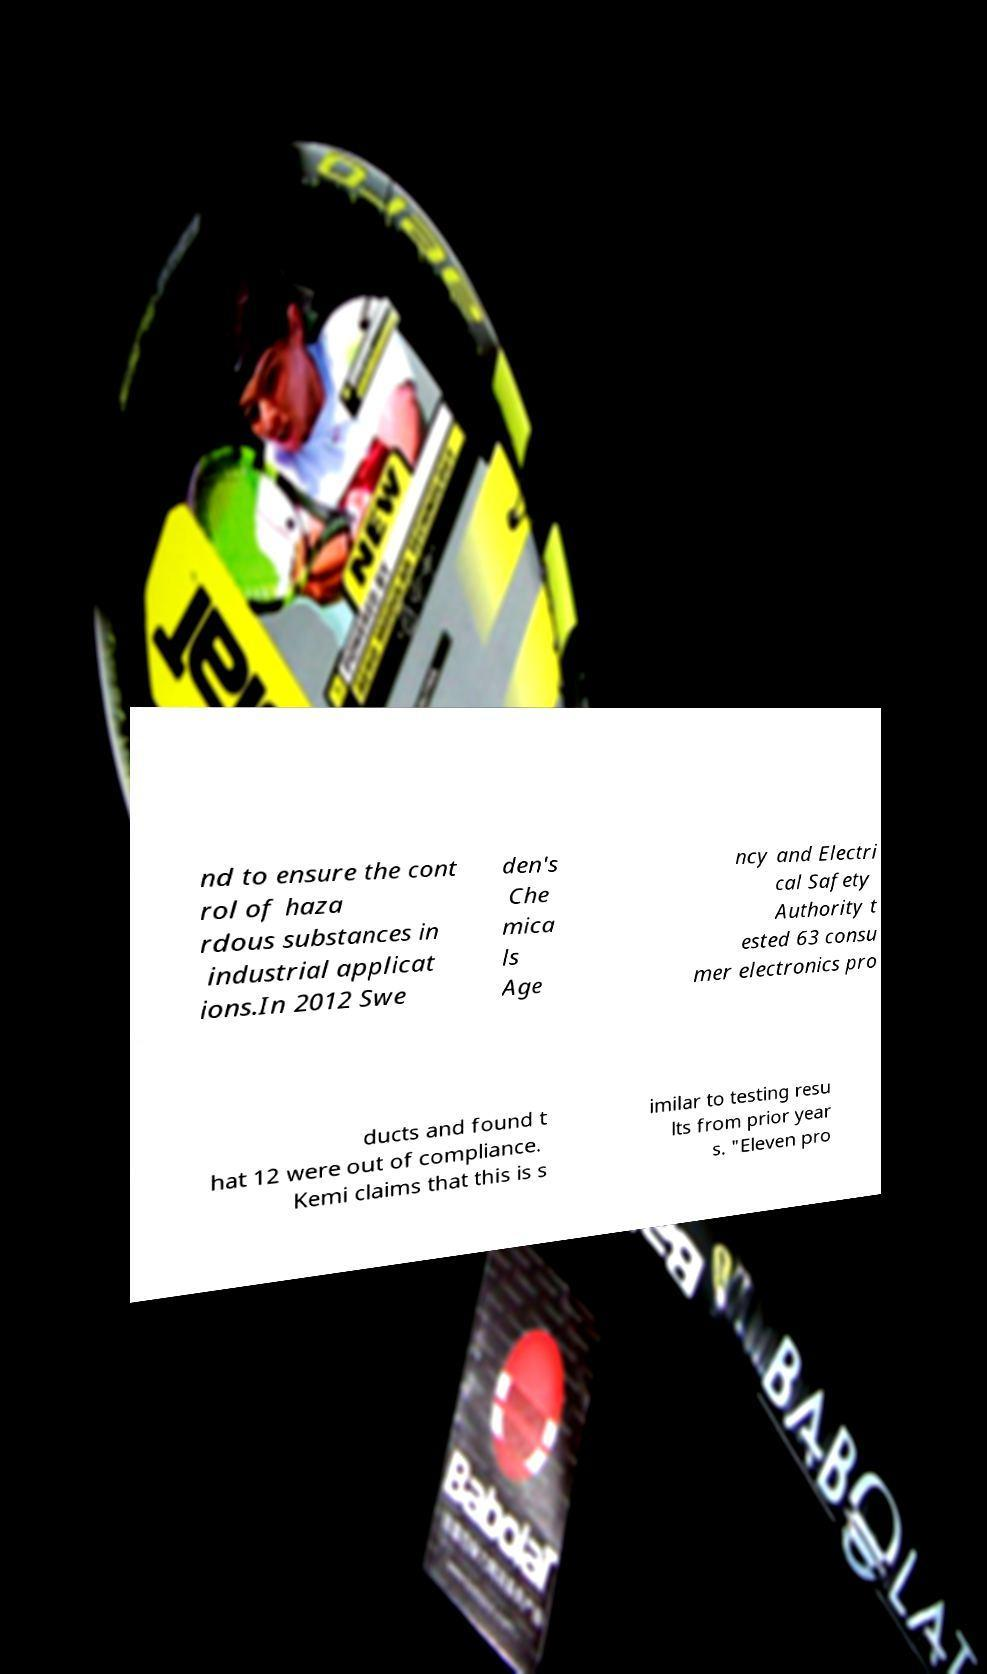What messages or text are displayed in this image? I need them in a readable, typed format. nd to ensure the cont rol of haza rdous substances in industrial applicat ions.In 2012 Swe den's Che mica ls Age ncy and Electri cal Safety Authority t ested 63 consu mer electronics pro ducts and found t hat 12 were out of compliance. Kemi claims that this is s imilar to testing resu lts from prior year s. "Eleven pro 